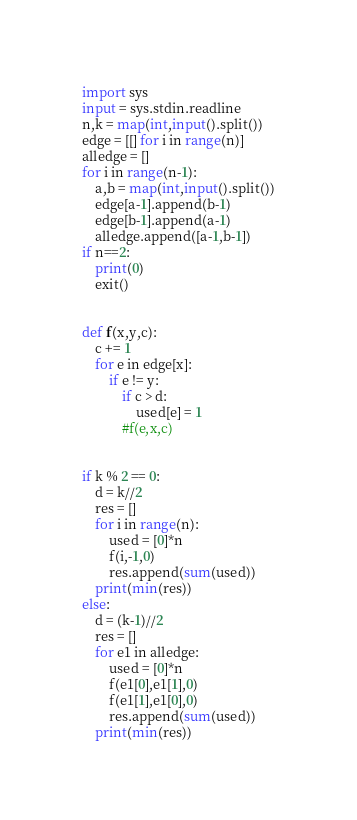<code> <loc_0><loc_0><loc_500><loc_500><_Python_>import sys
input = sys.stdin.readline
n,k = map(int,input().split())
edge = [[] for i in range(n)]
alledge = []
for i in range(n-1):
    a,b = map(int,input().split())
    edge[a-1].append(b-1)
    edge[b-1].append(a-1)
    alledge.append([a-1,b-1])
if n==2:
    print(0)
    exit()


def f(x,y,c):
    c += 1
    for e in edge[x]:
        if e != y:
            if c > d:
                used[e] = 1
            #f(e,x,c)


if k % 2 == 0:
    d = k//2
    res = []
    for i in range(n):
        used = [0]*n
        f(i,-1,0)
        res.append(sum(used))
    print(min(res))
else:
    d = (k-1)//2
    res = []
    for e1 in alledge:
        used = [0]*n
        f(e1[0],e1[1],0)
        f(e1[1],e1[0],0)
        res.append(sum(used))
    print(min(res))
</code> 